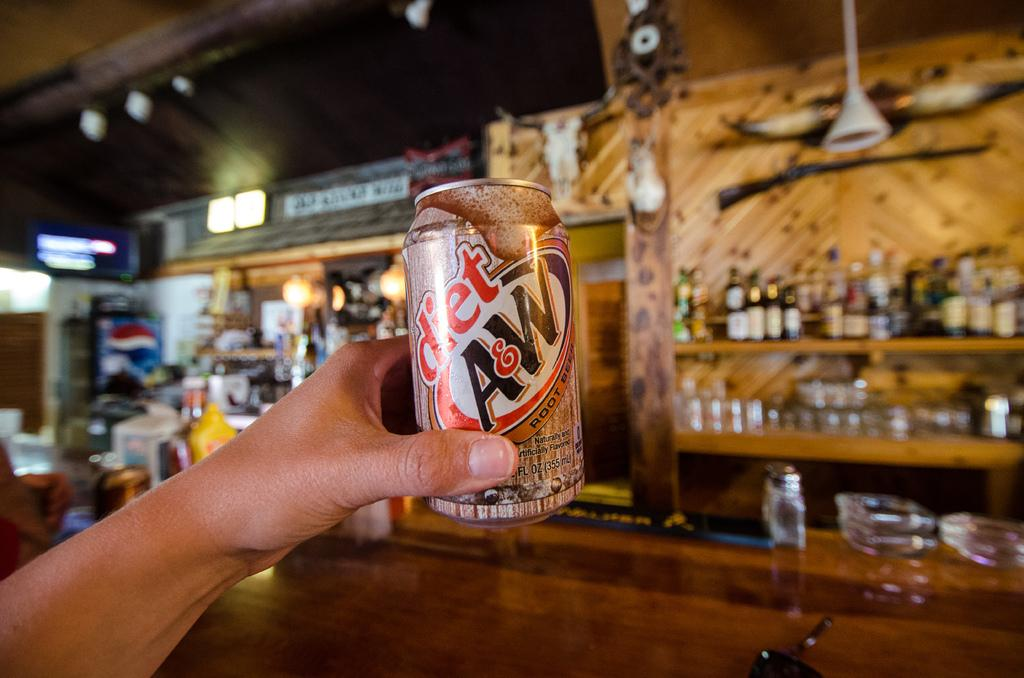What is the person in the image doing? The person's hand is holding a tin in the image. What can be seen in the background of the image? There are bottles, shelves, lights, wooden objects, and other unspecified objects in the background of the image. What type of pickle is being stored in the tin held by the person in the image? There is no pickle present in the image; the person is holding a tin, but its contents are not specified. 